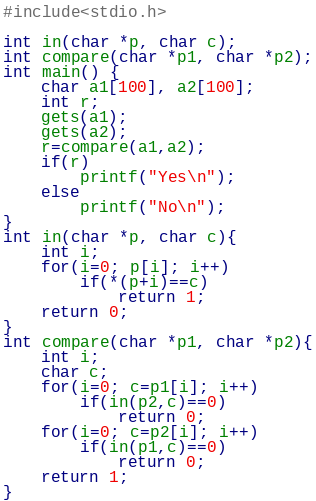Convert code to text. <code><loc_0><loc_0><loc_500><loc_500><_C_>#include<stdio.h>

int in(char *p, char c);
int compare(char *p1, char *p2);
int main() {
	char a1[100], a2[100];
	int r;
	gets(a1);
	gets(a2);
	r=compare(a1,a2);
	if(r)
		printf("Yes\n");
	else
		printf("No\n");
}
int in(char *p, char c){
	int i;
	for(i=0; p[i]; i++)
		if(*(p+i)==c)
			return 1;
	return 0;
}
int compare(char *p1, char *p2){
	int i;
	char c;
	for(i=0; c=p1[i]; i++)
		if(in(p2,c)==0)
			return 0;
	for(i=0; c=p2[i]; i++)
		if(in(p1,c)==0)
			return 0;
	return 1;
}</code> 